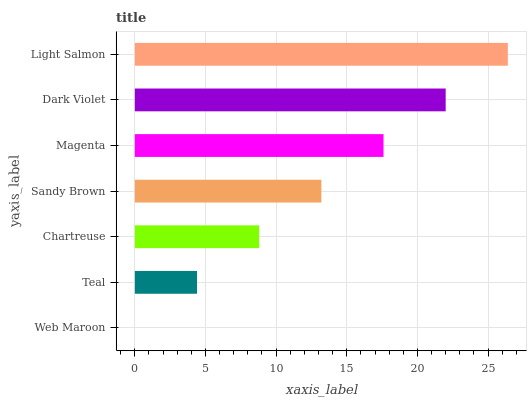Is Web Maroon the minimum?
Answer yes or no. Yes. Is Light Salmon the maximum?
Answer yes or no. Yes. Is Teal the minimum?
Answer yes or no. No. Is Teal the maximum?
Answer yes or no. No. Is Teal greater than Web Maroon?
Answer yes or no. Yes. Is Web Maroon less than Teal?
Answer yes or no. Yes. Is Web Maroon greater than Teal?
Answer yes or no. No. Is Teal less than Web Maroon?
Answer yes or no. No. Is Sandy Brown the high median?
Answer yes or no. Yes. Is Sandy Brown the low median?
Answer yes or no. Yes. Is Dark Violet the high median?
Answer yes or no. No. Is Teal the low median?
Answer yes or no. No. 